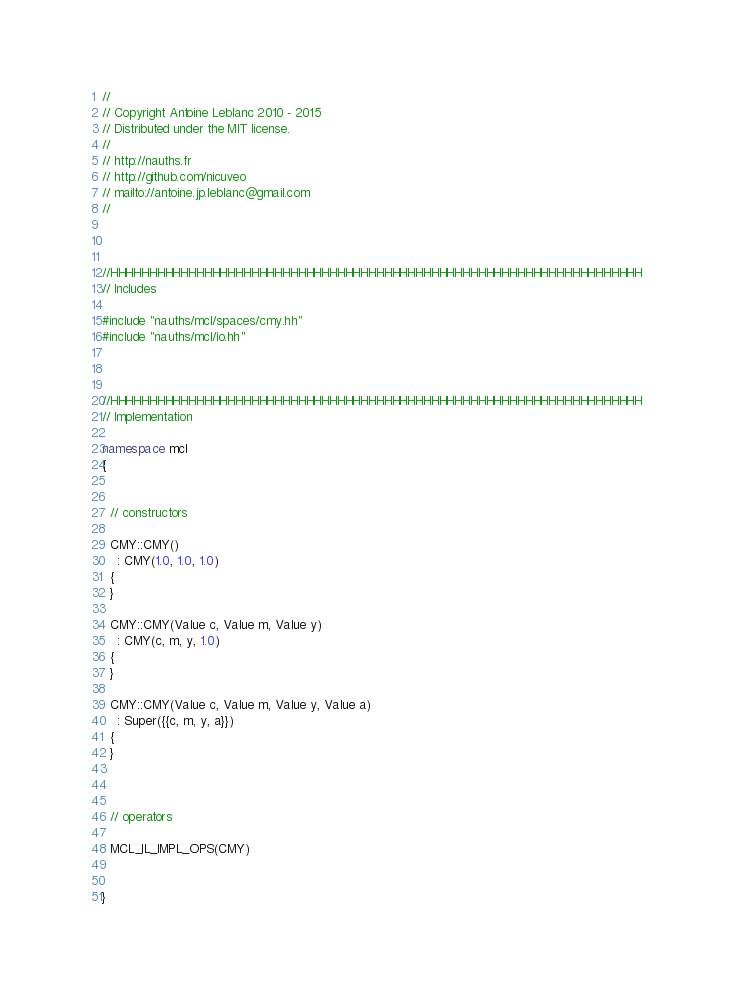Convert code to text. <code><loc_0><loc_0><loc_500><loc_500><_C++_>//
// Copyright Antoine Leblanc 2010 - 2015
// Distributed under the MIT license.
//
// http://nauths.fr
// http://github.com/nicuveo
// mailto://antoine.jp.leblanc@gmail.com
//



//HHHHHHHHHHHHHHHHHHHHHHHHHHHHHHHHHHHHHHHHHHHHHHHHHHHHHHHHHHHHHHHHHHHH
// Includes

#include "nauths/mcl/spaces/cmy.hh"
#include "nauths/mcl/io.hh"



//HHHHHHHHHHHHHHHHHHHHHHHHHHHHHHHHHHHHHHHHHHHHHHHHHHHHHHHHHHHHHHHHHHHH
// Implementation

namespace mcl
{


  // constructors

  CMY::CMY()
    : CMY(1.0, 1.0, 1.0)
  {
  }

  CMY::CMY(Value c, Value m, Value y)
    : CMY(c, m, y, 1.0)
  {
  }

  CMY::CMY(Value c, Value m, Value y, Value a)
    : Super({{c, m, y, a}})
  {
  }



  // operators

  MCL_IL_IMPL_OPS(CMY)


}
</code> 